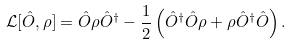<formula> <loc_0><loc_0><loc_500><loc_500>\mathcal { L } [ \hat { O } , \rho ] = \hat { O } \rho \hat { O } ^ { \dagger } - \frac { 1 } { 2 } \left ( \hat { O } ^ { \dagger } \hat { O } \rho + \rho \hat { O } ^ { \dagger } \hat { O } \right ) .</formula> 